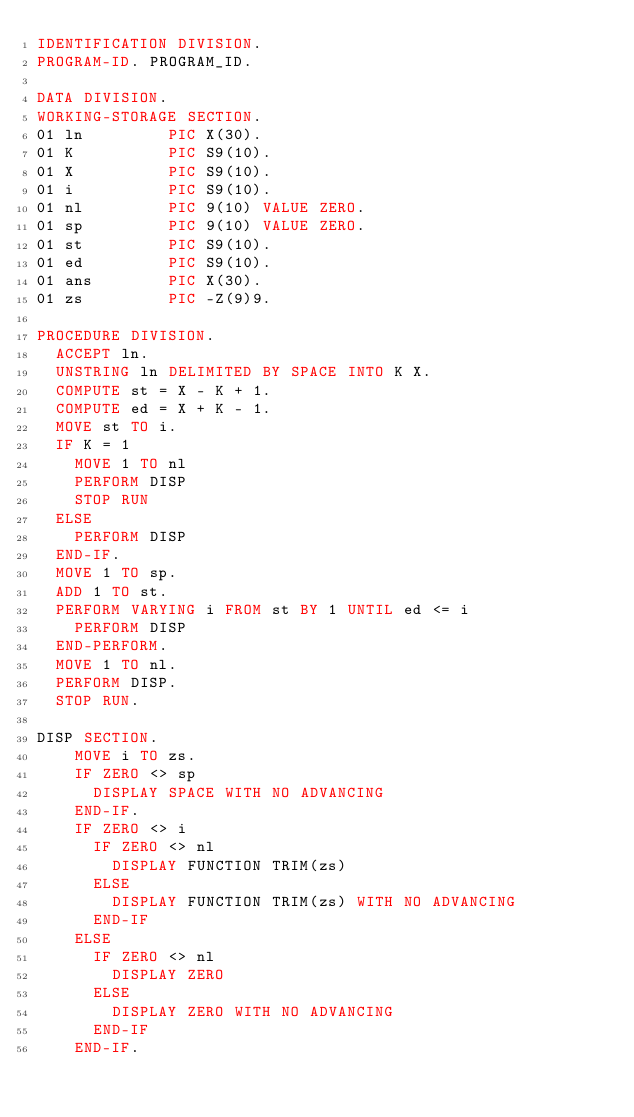Convert code to text. <code><loc_0><loc_0><loc_500><loc_500><_COBOL_>IDENTIFICATION DIVISION.
PROGRAM-ID. PROGRAM_ID.

DATA DIVISION.
WORKING-STORAGE SECTION.
01 ln         PIC X(30).
01 K          PIC S9(10).
01 X          PIC S9(10).
01 i          PIC S9(10).
01 nl         PIC 9(10) VALUE ZERO.
01 sp         PIC 9(10) VALUE ZERO.
01 st         PIC S9(10).
01 ed         PIC S9(10).
01 ans        PIC X(30).
01 zs         PIC -Z(9)9.

PROCEDURE DIVISION.
  ACCEPT ln.
  UNSTRING ln DELIMITED BY SPACE INTO K X.
  COMPUTE st = X - K + 1.
  COMPUTE ed = X + K - 1.
  MOVE st TO i.
  IF K = 1
    MOVE 1 TO nl
    PERFORM DISP
    STOP RUN
  ELSE
    PERFORM DISP
  END-IF.
  MOVE 1 TO sp.
  ADD 1 TO st.
  PERFORM VARYING i FROM st BY 1 UNTIL ed <= i
    PERFORM DISP
  END-PERFORM.
  MOVE 1 TO nl.
  PERFORM DISP.
  STOP RUN.

DISP SECTION.
    MOVE i TO zs.
    IF ZERO <> sp
      DISPLAY SPACE WITH NO ADVANCING
    END-IF.
    IF ZERO <> i
      IF ZERO <> nl
        DISPLAY FUNCTION TRIM(zs)
      ELSE
        DISPLAY FUNCTION TRIM(zs) WITH NO ADVANCING
      END-IF
    ELSE
      IF ZERO <> nl
        DISPLAY ZERO
      ELSE
        DISPLAY ZERO WITH NO ADVANCING
      END-IF
    END-IF.
</code> 